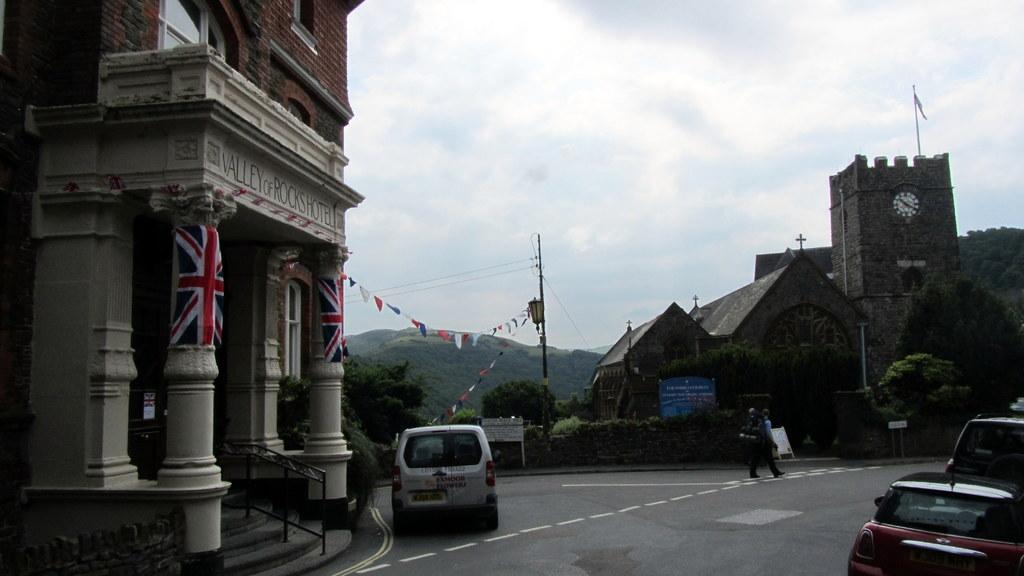<image>
Render a clear and concise summary of the photo. an open street next to the Valley of Rocks Hotel 